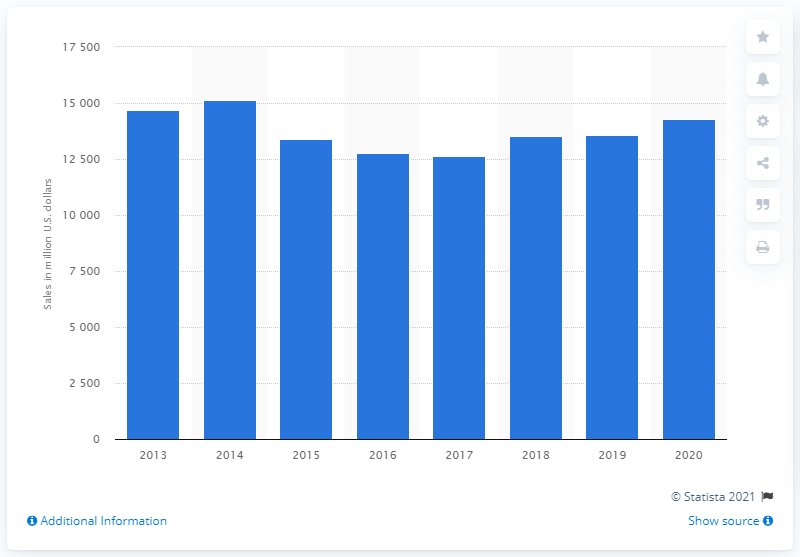Highlight a few significant elements in this photo. In 2014, Syngenta's global sales were 15,134. In 2020, Syngenta's global sales were 14,287. 